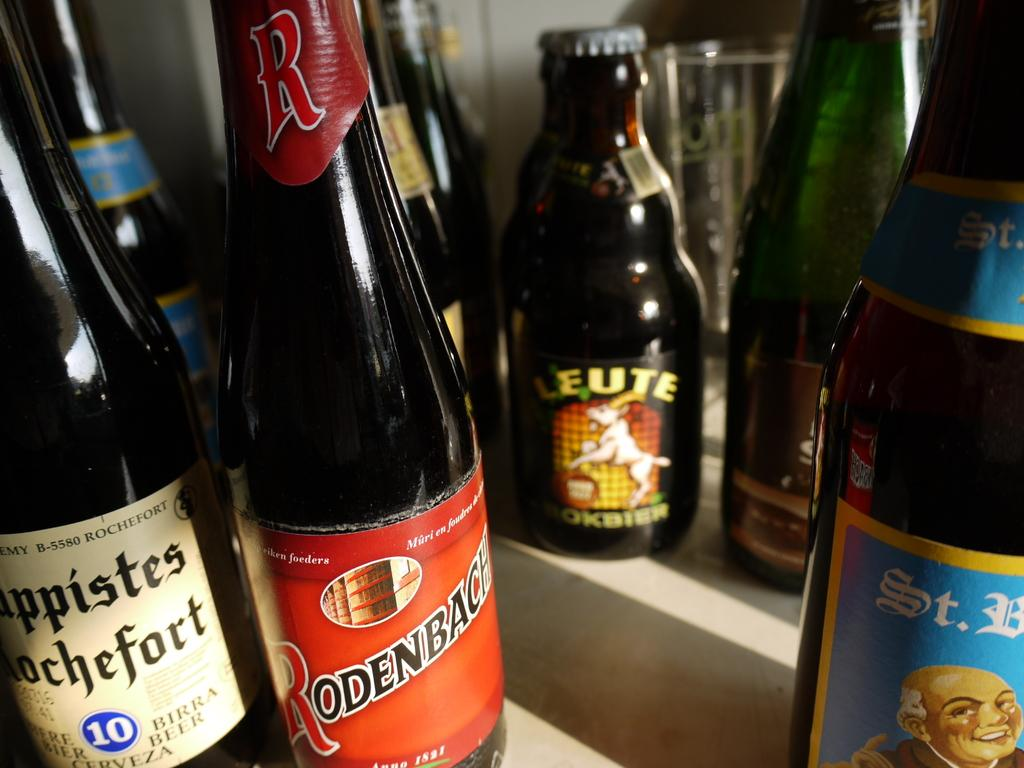What objects are present in large quantities in the image? There are many bottles in the image. Where are the bottles located? The bottles are on a table. How many clocks can be seen on the table with the bottles? There are no clocks visible in the image; it only shows bottles on a table. 